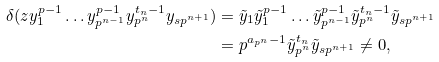<formula> <loc_0><loc_0><loc_500><loc_500>\delta ( z y _ { 1 } ^ { p - 1 } \dots y _ { p ^ { n - 1 } } ^ { p - 1 } y _ { p ^ { n } } ^ { { t _ { n } } - 1 } y _ { s p ^ { n + 1 } } ) & = \tilde { y } _ { 1 } \tilde { y } _ { 1 } ^ { p - 1 } \dots \tilde { y } _ { p ^ { n - 1 } } ^ { p - 1 } \tilde { y } _ { p ^ { n } } ^ { { t _ { n } } - 1 } \tilde { y } _ { s p ^ { n + 1 } } \\ & = p ^ { a _ { p ^ { n } } - 1 } \tilde { y } _ { p ^ { n } } ^ { t _ { n } } \tilde { y } _ { s p ^ { n + 1 } } \neq 0 ,</formula> 